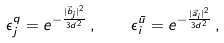Convert formula to latex. <formula><loc_0><loc_0><loc_500><loc_500>\epsilon ^ { q } _ { j } = e ^ { - \frac { | \vec { b } _ { j } | ^ { 2 } } { 3 d ^ { 2 } } } \, , \quad \epsilon ^ { \bar { u } } _ { i } = e ^ { - \frac { | \vec { a } _ { i } | ^ { 2 } } { 3 d ^ { 2 } } } \, ,</formula> 